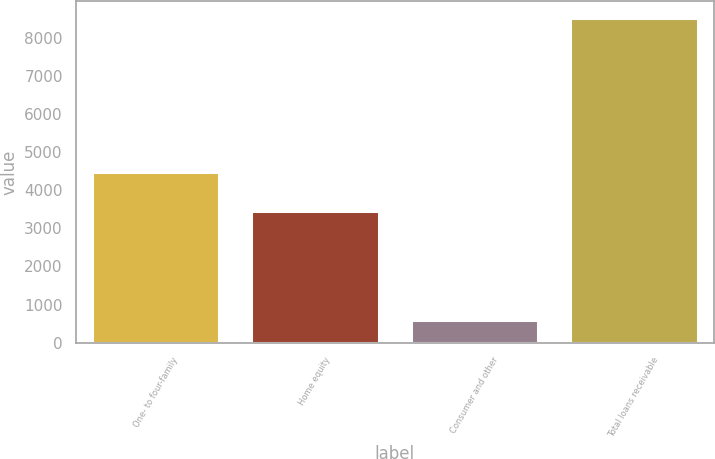<chart> <loc_0><loc_0><loc_500><loc_500><bar_chart><fcel>One- to four-family<fcel>Home equity<fcel>Consumer and other<fcel>Total loans receivable<nl><fcel>4475<fcel>3454<fcel>602<fcel>8531<nl></chart> 